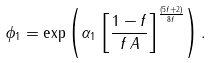Convert formula to latex. <formula><loc_0><loc_0><loc_500><loc_500>\phi _ { 1 } = \exp \left ( \alpha _ { 1 } \, \left [ \frac { 1 - f } { f \, A } \right ] ^ { \frac { ( 5 f + 2 ) } { 8 f } } \right ) .</formula> 